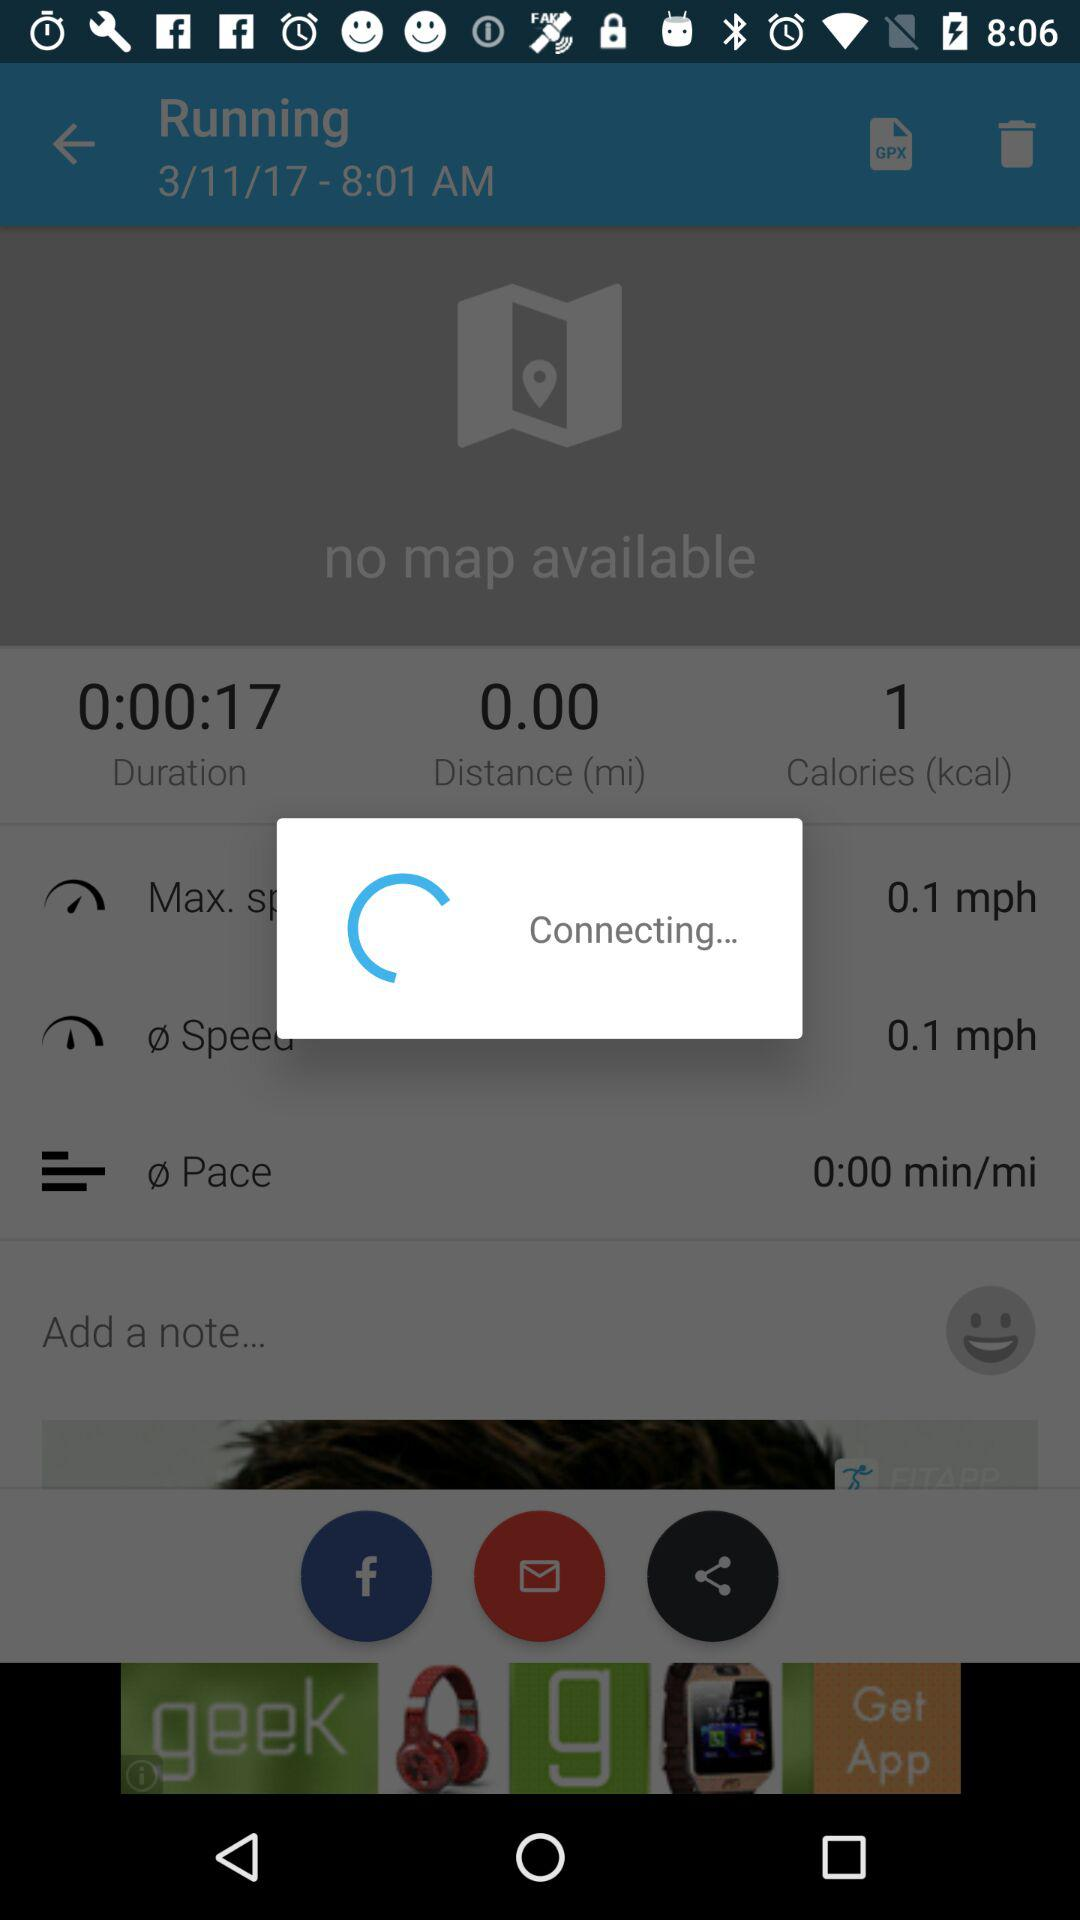What is the duration? The duration is 0:00:17. 